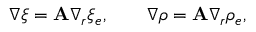Convert formula to latex. <formula><loc_0><loc_0><loc_500><loc_500>\nabla \xi = { A } \nabla _ { r } \xi _ { e } , \quad \nabla \rho = { A } \nabla _ { r } \rho _ { e } ,</formula> 